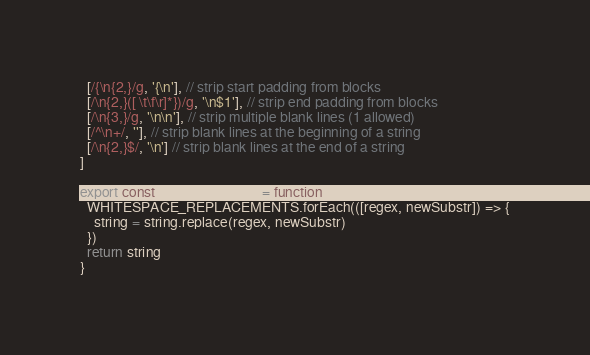Convert code to text. <code><loc_0><loc_0><loc_500><loc_500><_JavaScript_>  [/{\n{2,}/g, '{\n'], // strip start padding from blocks
  [/\n{2,}([ \t\f\r]*})/g, '\n$1'], // strip end padding from blocks
  [/\n{3,}/g, '\n\n'], // strip multiple blank lines (1 allowed)
  [/^\n+/, ''], // strip blank lines at the beginning of a string
  [/\n{2,}$/, '\n'] // strip blank lines at the end of a string
]

export const stripWhitespace = function stripWhitespace (string) {
  WHITESPACE_REPLACEMENTS.forEach(([regex, newSubstr]) => {
    string = string.replace(regex, newSubstr)
  })
  return string
}
</code> 